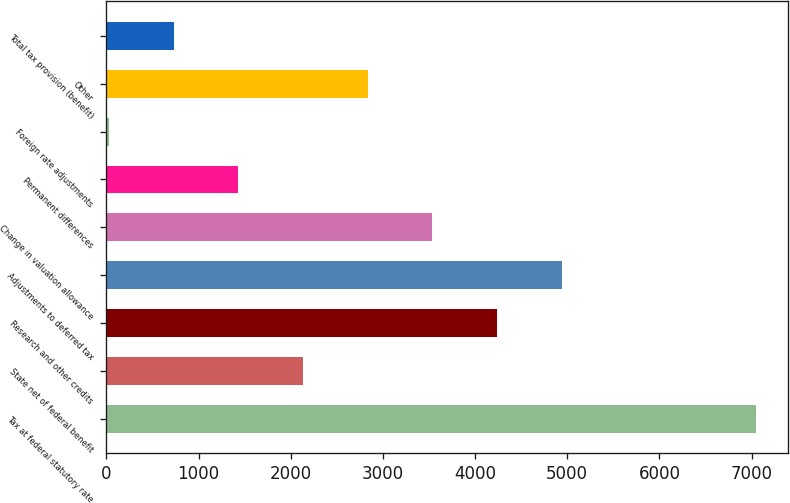Convert chart. <chart><loc_0><loc_0><loc_500><loc_500><bar_chart><fcel>Tax at federal statutory rate<fcel>State net of federal benefit<fcel>Research and other credits<fcel>Adjustments to deferred tax<fcel>Change in valuation allowance<fcel>Permanent differences<fcel>Foreign rate adjustments<fcel>Other<fcel>Total tax provision (benefit)<nl><fcel>7043<fcel>2132.5<fcel>4237<fcel>4938.5<fcel>3535.5<fcel>1431<fcel>28<fcel>2834<fcel>729.5<nl></chart> 